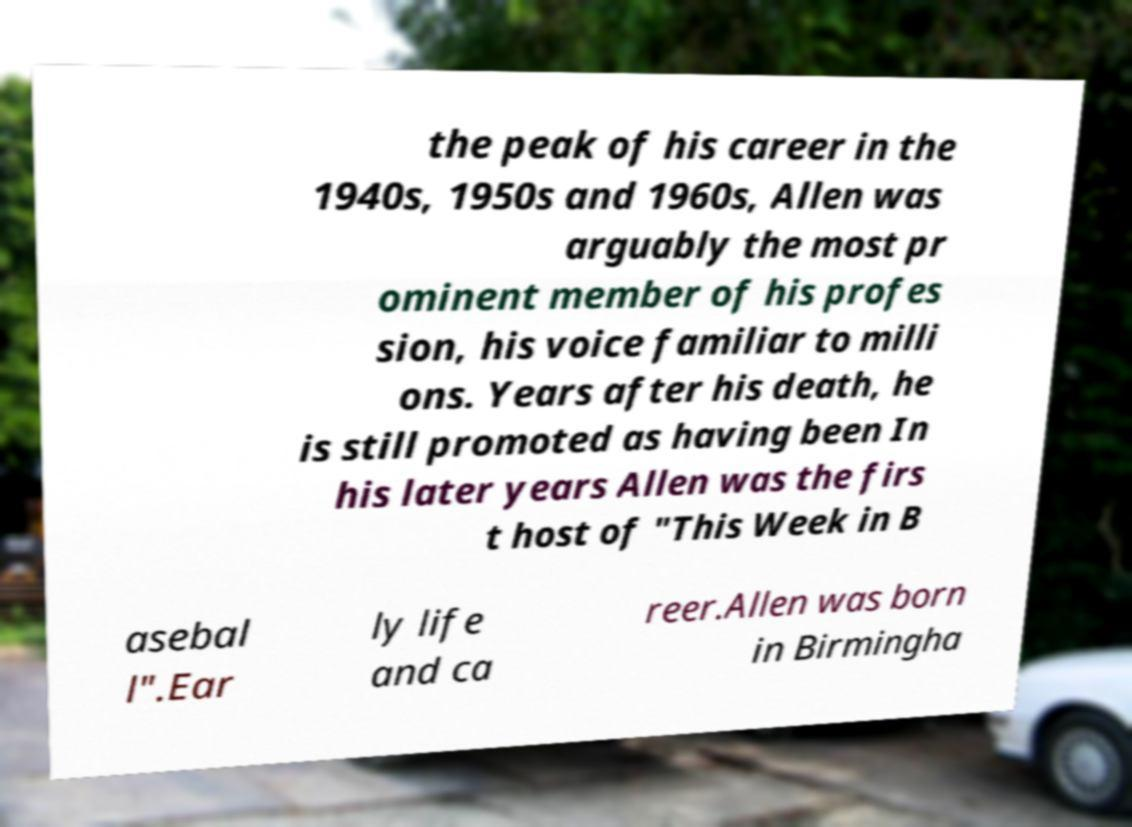Can you read and provide the text displayed in the image?This photo seems to have some interesting text. Can you extract and type it out for me? the peak of his career in the 1940s, 1950s and 1960s, Allen was arguably the most pr ominent member of his profes sion, his voice familiar to milli ons. Years after his death, he is still promoted as having been In his later years Allen was the firs t host of "This Week in B asebal l".Ear ly life and ca reer.Allen was born in Birmingha 